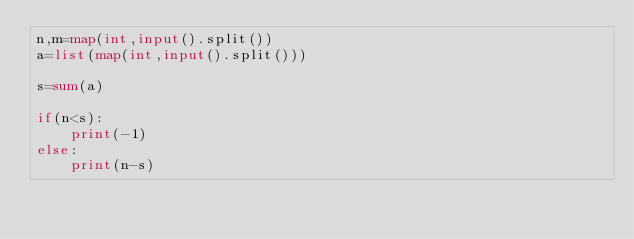<code> <loc_0><loc_0><loc_500><loc_500><_Python_>n,m=map(int,input().split())
a=list(map(int,input().split()))

s=sum(a)

if(n<s):
    print(-1)
else:
    print(n-s)</code> 